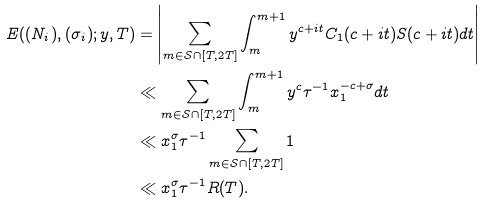Convert formula to latex. <formula><loc_0><loc_0><loc_500><loc_500>E ( ( N _ { i } ) , ( \sigma _ { i } ) ; y , T ) & = \left | \sum _ { m \in \mathcal { S } \cap [ T , 2 T ] } \int _ { m } ^ { m + 1 } y ^ { c + i t } C _ { 1 } ( c + i t ) S ( c + i t ) d t \right | \\ & \ll \sum _ { m \in \mathcal { S } \cap [ T , 2 T ] } \int _ { m } ^ { m + 1 } y ^ { c } \tau ^ { - 1 } x _ { 1 } ^ { - c + \sigma } d t \\ & \ll x _ { 1 } ^ { \sigma } \tau ^ { - 1 } \sum _ { m \in \mathcal { S } \cap [ T , 2 T ] } 1 \\ & \ll x _ { 1 } ^ { \sigma } \tau ^ { - 1 } R ( T ) .</formula> 